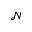Convert formula to latex. <formula><loc_0><loc_0><loc_500><loc_500>\mathcal { N }</formula> 